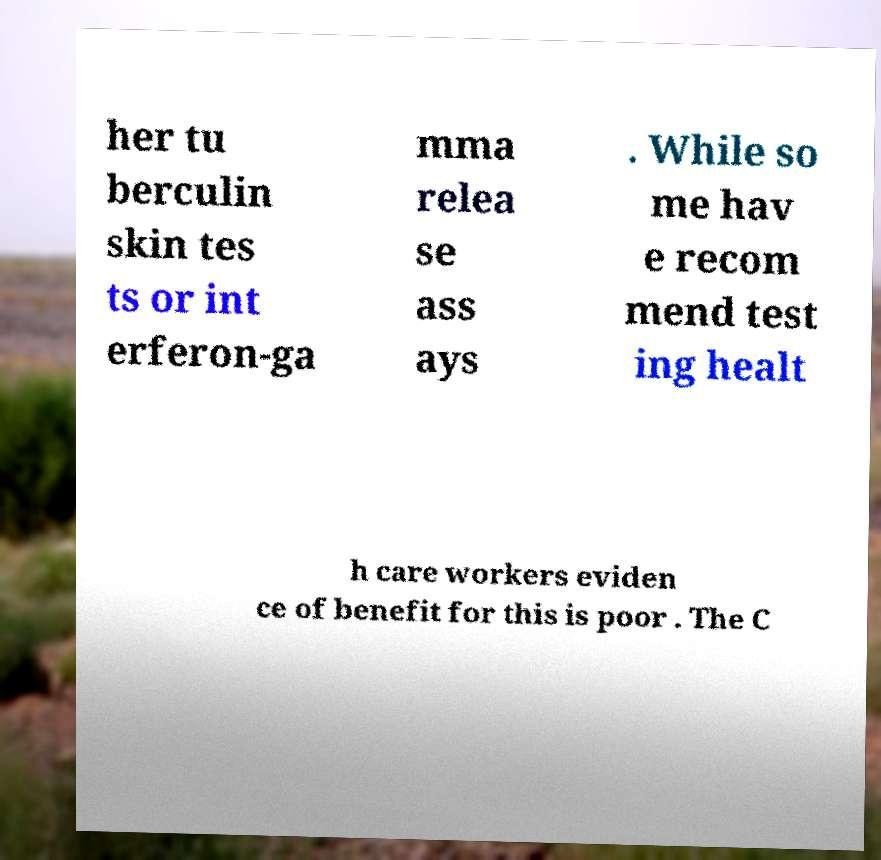There's text embedded in this image that I need extracted. Can you transcribe it verbatim? her tu berculin skin tes ts or int erferon-ga mma relea se ass ays . While so me hav e recom mend test ing healt h care workers eviden ce of benefit for this is poor . The C 